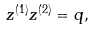<formula> <loc_0><loc_0><loc_500><loc_500>z ^ { ( 1 ) } z ^ { ( 2 ) } = q ,</formula> 